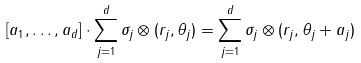<formula> <loc_0><loc_0><loc_500><loc_500>[ a _ { 1 } , \dots , a _ { d } ] \cdot \sum _ { j = 1 } ^ { d } \sigma _ { j } \otimes ( r _ { j } , \theta _ { j } ) = \sum _ { j = 1 } ^ { d } \sigma _ { j } \otimes ( r _ { j } , \theta _ { j } + a _ { j } )</formula> 